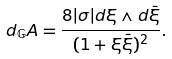Convert formula to latex. <formula><loc_0><loc_0><loc_500><loc_500>d _ { \mathbb { G } } A = \frac { 8 | \sigma | d \xi \wedge d \bar { \xi } } { ( 1 + \xi \bar { \xi } ) ^ { 2 } } .</formula> 